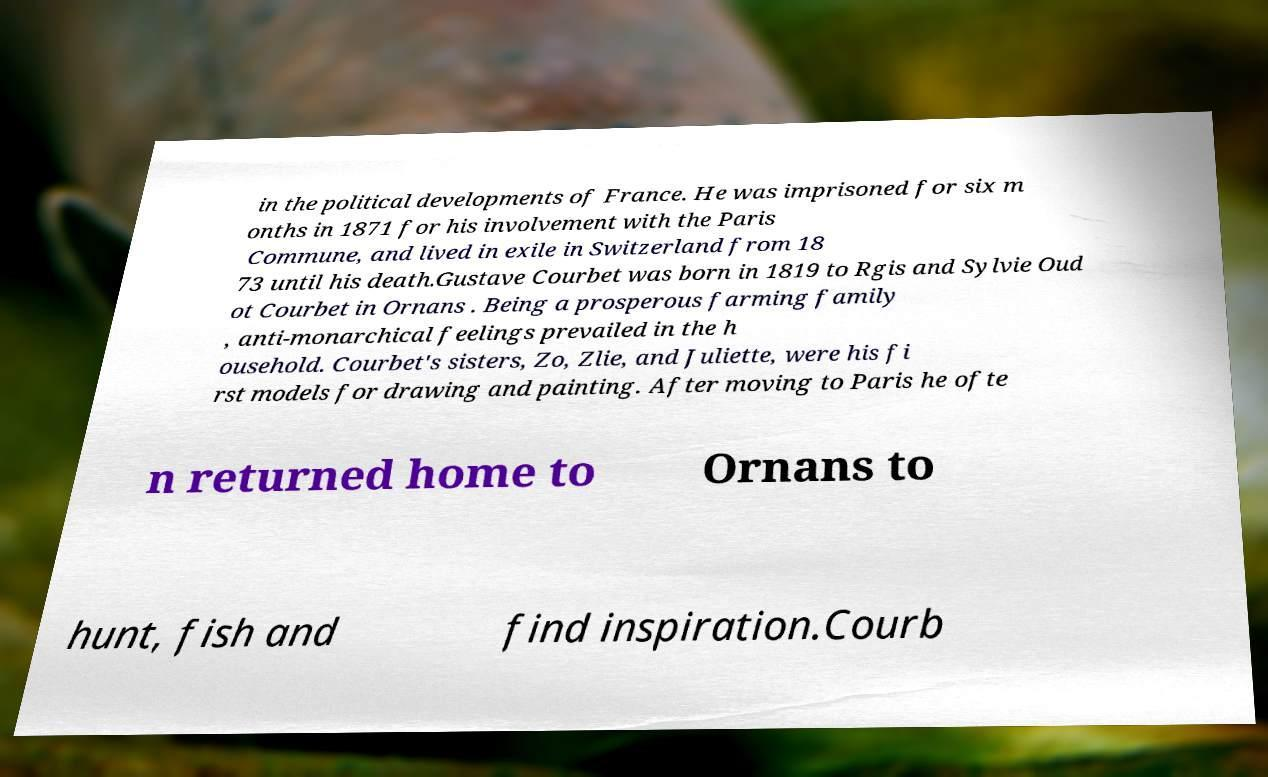Could you extract and type out the text from this image? in the political developments of France. He was imprisoned for six m onths in 1871 for his involvement with the Paris Commune, and lived in exile in Switzerland from 18 73 until his death.Gustave Courbet was born in 1819 to Rgis and Sylvie Oud ot Courbet in Ornans . Being a prosperous farming family , anti-monarchical feelings prevailed in the h ousehold. Courbet's sisters, Zo, Zlie, and Juliette, were his fi rst models for drawing and painting. After moving to Paris he ofte n returned home to Ornans to hunt, fish and find inspiration.Courb 